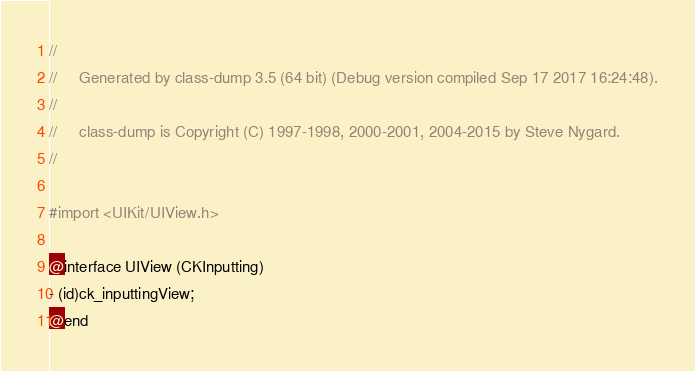<code> <loc_0><loc_0><loc_500><loc_500><_C_>//
//     Generated by class-dump 3.5 (64 bit) (Debug version compiled Sep 17 2017 16:24:48).
//
//     class-dump is Copyright (C) 1997-1998, 2000-2001, 2004-2015 by Steve Nygard.
//

#import <UIKit/UIView.h>

@interface UIView (CKInputting)
- (id)ck_inputtingView;
@end

</code> 